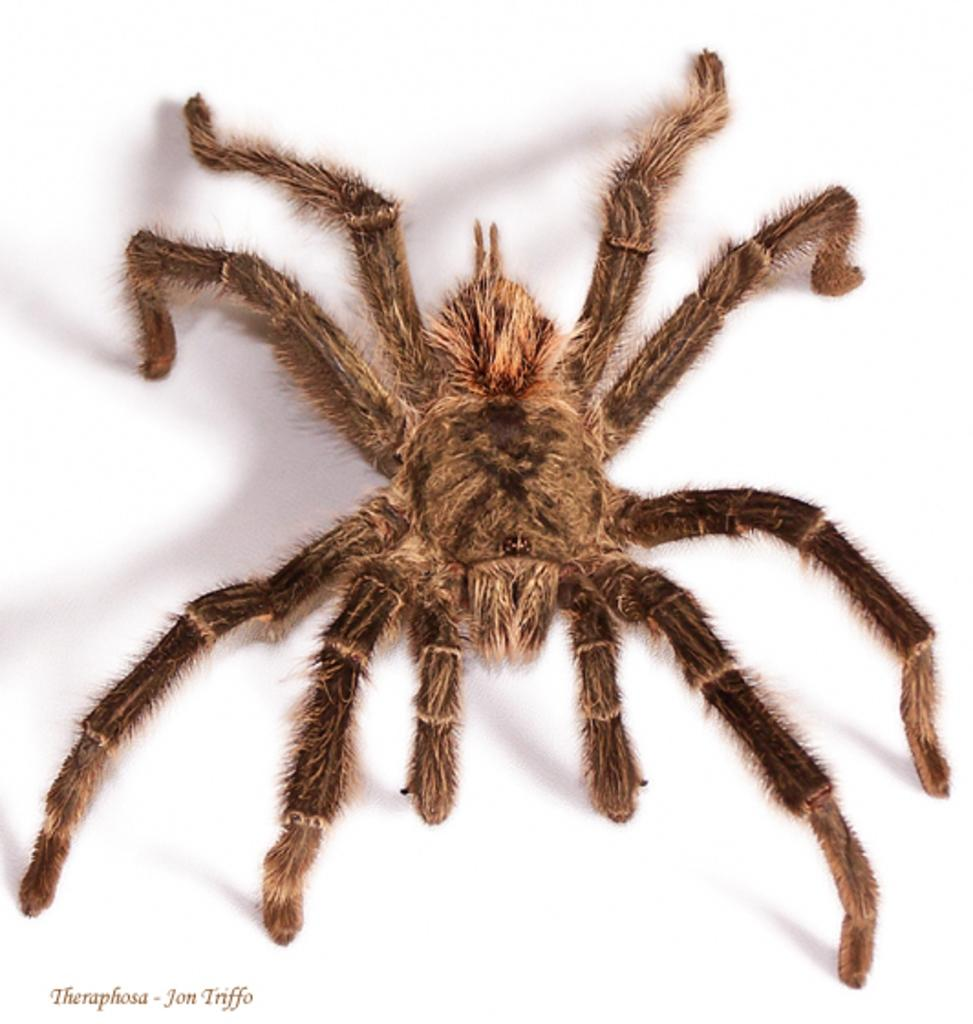What is the main subject of the image? There is a spider in the image. Where is the text located in the image? The text is on the bottom left side of the image. What color is the background of the image? The background of the image is white. What is the girl doing on the swing in the image? There is no girl or swing present in the image; it only features a spider and text on a white background. 